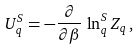Convert formula to latex. <formula><loc_0><loc_0><loc_500><loc_500>U _ { q } ^ { S } = - \frac { \partial } { \partial \beta } \, \ln _ { q } ^ { S } Z _ { q } \, ,</formula> 